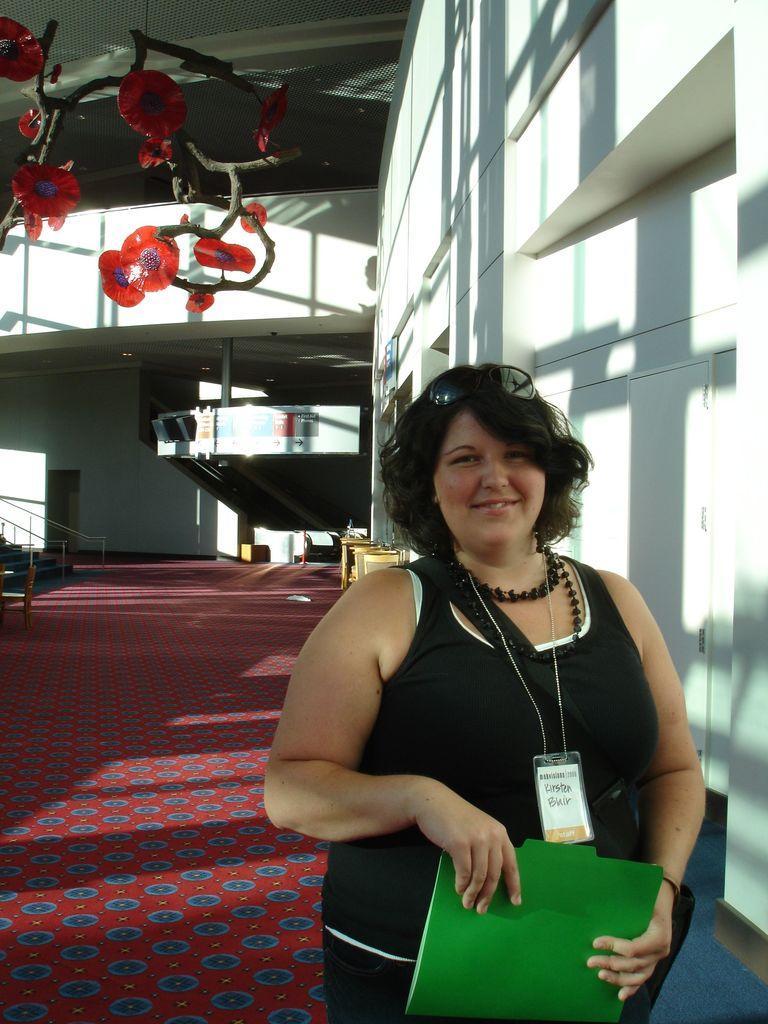In one or two sentences, can you explain what this image depicts? In this image, I can see a woman standing and holding a file. On the right side of the image, I can see a wall. At the top left side of the image, I can see a decorative item hanging to a ceiling. On the right side of the image, there are stairs. At the bottom of the image, I can see a carpet on the floor. In the background, there are few objects. 